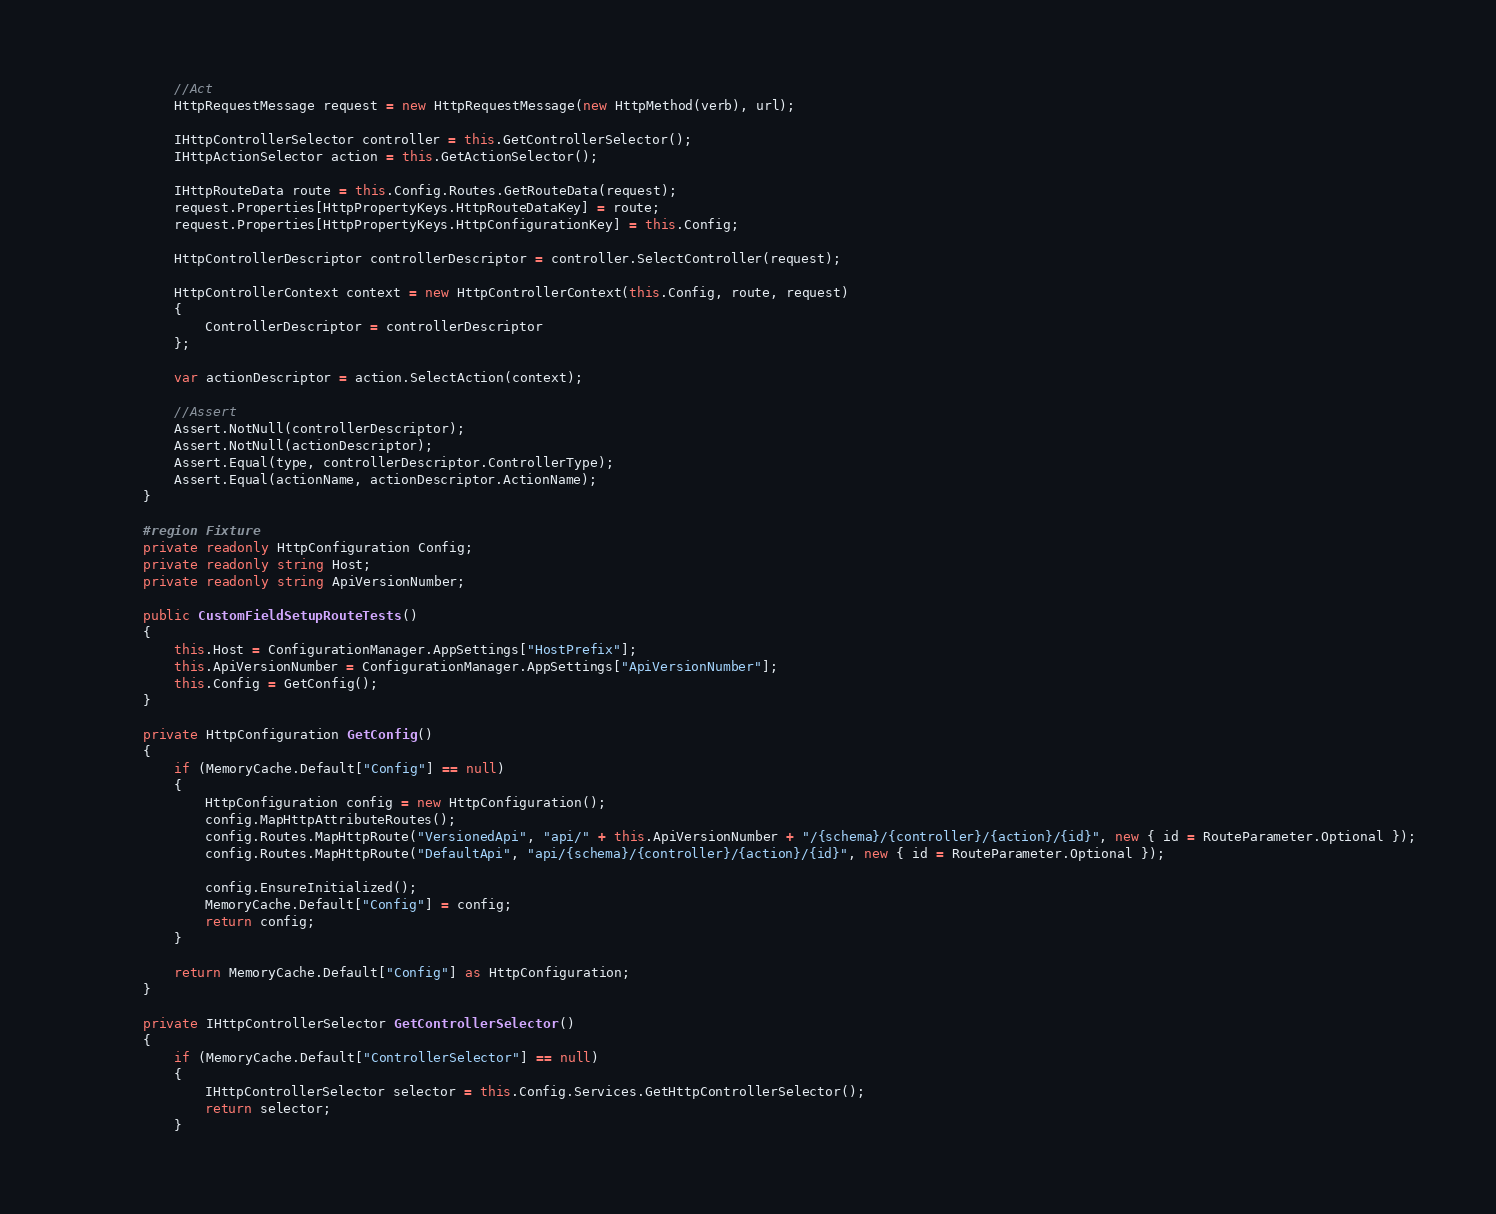<code> <loc_0><loc_0><loc_500><loc_500><_C#_>            //Act
            HttpRequestMessage request = new HttpRequestMessage(new HttpMethod(verb), url);

            IHttpControllerSelector controller = this.GetControllerSelector();
            IHttpActionSelector action = this.GetActionSelector();

            IHttpRouteData route = this.Config.Routes.GetRouteData(request);
            request.Properties[HttpPropertyKeys.HttpRouteDataKey] = route;
            request.Properties[HttpPropertyKeys.HttpConfigurationKey] = this.Config;

            HttpControllerDescriptor controllerDescriptor = controller.SelectController(request);

            HttpControllerContext context = new HttpControllerContext(this.Config, route, request)
            {
                ControllerDescriptor = controllerDescriptor
            };

            var actionDescriptor = action.SelectAction(context);

            //Assert
            Assert.NotNull(controllerDescriptor);
            Assert.NotNull(actionDescriptor);
            Assert.Equal(type, controllerDescriptor.ControllerType);
            Assert.Equal(actionName, actionDescriptor.ActionName);
        }

        #region Fixture
        private readonly HttpConfiguration Config;
        private readonly string Host;
        private readonly string ApiVersionNumber;

        public CustomFieldSetupRouteTests()
        {
            this.Host = ConfigurationManager.AppSettings["HostPrefix"];
            this.ApiVersionNumber = ConfigurationManager.AppSettings["ApiVersionNumber"];
            this.Config = GetConfig();
        }

        private HttpConfiguration GetConfig()
        {
            if (MemoryCache.Default["Config"] == null)
            {
                HttpConfiguration config = new HttpConfiguration();
                config.MapHttpAttributeRoutes();
                config.Routes.MapHttpRoute("VersionedApi", "api/" + this.ApiVersionNumber + "/{schema}/{controller}/{action}/{id}", new { id = RouteParameter.Optional });
                config.Routes.MapHttpRoute("DefaultApi", "api/{schema}/{controller}/{action}/{id}", new { id = RouteParameter.Optional });

                config.EnsureInitialized();
                MemoryCache.Default["Config"] = config;
                return config;
            }

            return MemoryCache.Default["Config"] as HttpConfiguration;
        }

        private IHttpControllerSelector GetControllerSelector()
        {
            if (MemoryCache.Default["ControllerSelector"] == null)
            {
                IHttpControllerSelector selector = this.Config.Services.GetHttpControllerSelector();
                return selector;
            }
</code> 